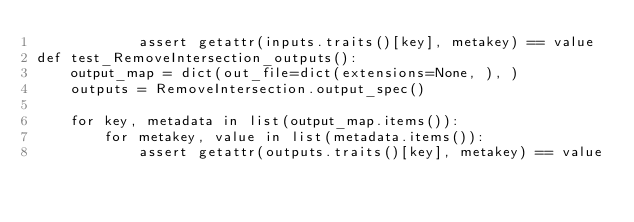<code> <loc_0><loc_0><loc_500><loc_500><_Python_>            assert getattr(inputs.traits()[key], metakey) == value
def test_RemoveIntersection_outputs():
    output_map = dict(out_file=dict(extensions=None, ), )
    outputs = RemoveIntersection.output_spec()

    for key, metadata in list(output_map.items()):
        for metakey, value in list(metadata.items()):
            assert getattr(outputs.traits()[key], metakey) == value
</code> 